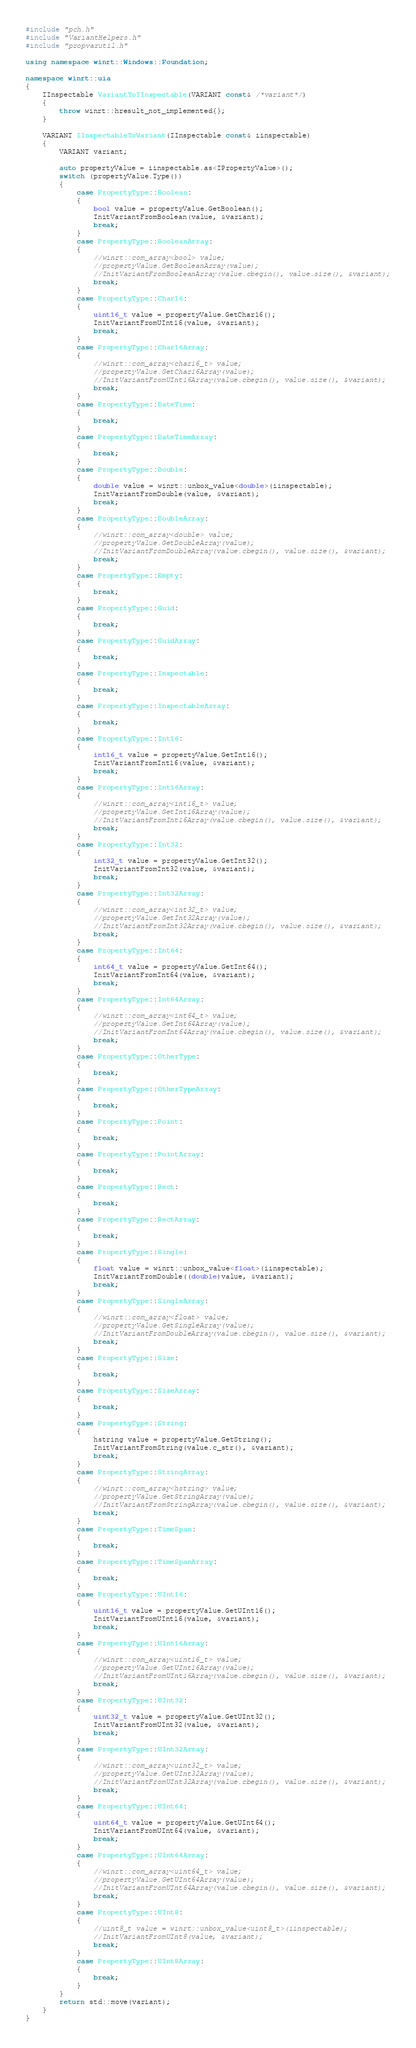<code> <loc_0><loc_0><loc_500><loc_500><_C++_>#include "pch.h"
#include "VariantHelpers.h"
#include "propvarutil.h"

using namespace winrt::Windows::Foundation;

namespace winrt::uia
{
	IInspectable VariantToIInspectable(VARIANT const& /*variant*/)
	{
		throw winrt::hresult_not_implemented{};
	}

	VARIANT IInspectableToVariant(IInspectable const& iinspectable)
	{
		VARIANT variant;

		auto propertyValue = iinspectable.as<IPropertyValue>();
		switch (propertyValue.Type())
		{
			case PropertyType::Boolean:
			{
				bool value = propertyValue.GetBoolean();
				InitVariantFromBoolean(value, &variant);
				break;
			}
			case PropertyType::BooleanArray:
			{
				//winrt::com_array<bool> value;
				//propertyValue.GetBooleanArray(value);
				//InitVariantFromBooleanArray(value.cbegin(), value.size(), &variant);
				break;
			}
			case PropertyType::Char16:
			{
				uint16_t value = propertyValue.GetChar16();
				InitVariantFromUInt16(value, &variant);
				break;
			}
			case PropertyType::Char16Array:
			{
				//winrt::com_array<char16_t> value;
				//propertyValue.GetChar16Array(value);
				//InitVariantFromUInt16Array(value.cbegin(), value.size(), &variant);
				break;
			}
			case PropertyType::DateTime:
			{
				break;
			}
			case PropertyType::DateTimeArray:
			{
				break;
			}
			case PropertyType::Double:
			{
				double value = winrt::unbox_value<double>(iinspectable);
				InitVariantFromDouble(value, &variant);
				break;
			}
			case PropertyType::DoubleArray:
			{
				//winrt::com_array<double> value;
				//propertyValue.GetDoubleArray(value);
				//InitVariantFromDoubleArray(value.cbegin(), value.size(), &variant);
				break;
			}
			case PropertyType::Empty:
			{
				break;
			}
			case PropertyType::Guid:
			{
				break;
			}
			case PropertyType::GuidArray:
			{
				break;
			}
			case PropertyType::Inspectable:
			{
				break;
			}
			case PropertyType::InspectableArray:
			{
				break;
			}
			case PropertyType::Int16:
			{
				int16_t value = propertyValue.GetInt16();
				InitVariantFromInt16(value, &variant);
				break;
			}
			case PropertyType::Int16Array:
			{
				//winrt::com_array<int16_t> value;
				//propertyValue.GetInt16Array(value);
				//InitVariantFromInt16Array(value.cbegin(), value.size(), &variant);
				break;
			}
			case PropertyType::Int32:
			{
				int32_t value = propertyValue.GetInt32();
				InitVariantFromInt32(value, &variant);
				break;
			}
			case PropertyType::Int32Array:
			{
				//winrt::com_array<int32_t> value;
				//propertyValue.GetInt32Array(value);
				//InitVariantFromInt32Array(value.cbegin(), value.size(), &variant);
				break;
			}
			case PropertyType::Int64:
			{
				int64_t value = propertyValue.GetInt64();
				InitVariantFromInt64(value, &variant);
				break;
			}
			case PropertyType::Int64Array:
			{
				//winrt::com_array<int64_t> value;
				//propertyValue.GetInt64Array(value);
				//InitVariantFromInt64Array(value.cbegin(), value.size(), &variant);
				break;
			}
			case PropertyType::OtherType:
			{
				break;
			}
			case PropertyType::OtherTypeArray:
			{
				break;
			}
			case PropertyType::Point:
			{
				break;
			}
			case PropertyType::PointArray:
			{
				break;
			}
			case PropertyType::Rect:
			{
				break;
			}
			case PropertyType::RectArray:
			{
				break;
			}
			case PropertyType::Single:
			{
				float value = winrt::unbox_value<float>(iinspectable);
				InitVariantFromDouble((double)value, &variant);
				break;
			}
			case PropertyType::SingleArray:
			{
				//winrt::com_array<float> value;
				//propertyValue.GetSingleArray(value);
				//InitVariantFromDoubleArray(value.cbegin(), value.size(), &variant);
				break;
			}
			case PropertyType::Size:
			{
				break;
			}
			case PropertyType::SizeArray:
			{
				break;
			}
			case PropertyType::String:
			{
				hstring value = propertyValue.GetString();
				InitVariantFromString(value.c_str(), &variant);
				break;
			}
			case PropertyType::StringArray:
			{
				//winrt::com_array<hstring> value;
				//propertyValue.GetStringArray(value);
				//InitVariantFromStringArray(value.cbegin(), value.size(), &variant);
				break;
			}
			case PropertyType::TimeSpan:
			{
				break;
			}
			case PropertyType::TimeSpanArray:
			{
				break;
			}
			case PropertyType::UInt16:
			{
				uint16_t value = propertyValue.GetUInt16();
				InitVariantFromUInt16(value, &variant);
				break;
			}
			case PropertyType::UInt16Array:
			{
				//winrt::com_array<uint16_t> value;
				//propertyValue.GetUInt16Array(value);
				//InitVariantFromUInt16Array(value.cbegin(), value.size(), &variant);
				break;
			}
			case PropertyType::UInt32:
			{
				uint32_t value = propertyValue.GetUInt32();
				InitVariantFromUInt32(value, &variant);
				break;
			}
			case PropertyType::UInt32Array:
			{
				//winrt::com_array<uint32_t> value;
				//propertyValue.GetUInt32Array(value);
				//InitVariantFromUInt32Array(value.cbegin(), value.size(), &variant);
				break;
			}
			case PropertyType::UInt64:
			{
				uint64_t value = propertyValue.GetUInt64();
				InitVariantFromUInt64(value, &variant);
				break;
			}
			case PropertyType::UInt64Array:
			{
				//winrt::com_array<uint64_t> value;
				//propertyValue.GetUInt64Array(value);
				//InitVariantFromUInt64Array(value.cbegin(), value.size(), &variant);
				break;
			}
			case PropertyType::UInt8:
			{
				//uint8_t value = winrt::unbox_value<uint8_t>(iinspectable);
				//InitVariantFromUInt8(value, &variant);
				break;
			}
			case PropertyType::UInt8Array:
			{
				break;
			}
		}
		return std::move(variant);
	}
}</code> 